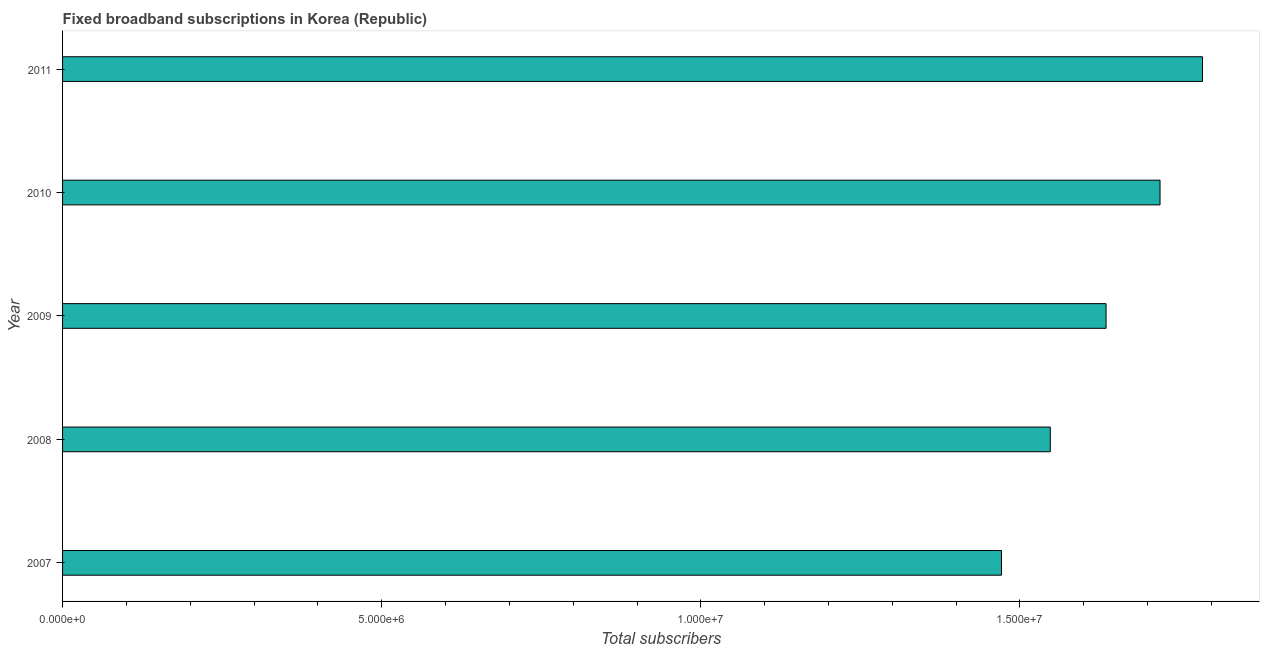Does the graph contain any zero values?
Your response must be concise. No. What is the title of the graph?
Keep it short and to the point. Fixed broadband subscriptions in Korea (Republic). What is the label or title of the X-axis?
Provide a short and direct response. Total subscribers. What is the total number of fixed broadband subscriptions in 2007?
Keep it short and to the point. 1.47e+07. Across all years, what is the maximum total number of fixed broadband subscriptions?
Keep it short and to the point. 1.79e+07. Across all years, what is the minimum total number of fixed broadband subscriptions?
Provide a succinct answer. 1.47e+07. In which year was the total number of fixed broadband subscriptions minimum?
Offer a terse response. 2007. What is the sum of the total number of fixed broadband subscriptions?
Offer a terse response. 8.16e+07. What is the difference between the total number of fixed broadband subscriptions in 2007 and 2009?
Offer a terse response. -1.64e+06. What is the average total number of fixed broadband subscriptions per year?
Your answer should be very brief. 1.63e+07. What is the median total number of fixed broadband subscriptions?
Your answer should be very brief. 1.63e+07. In how many years, is the total number of fixed broadband subscriptions greater than 2000000 ?
Make the answer very short. 5. What is the ratio of the total number of fixed broadband subscriptions in 2008 to that in 2011?
Provide a succinct answer. 0.87. Is the total number of fixed broadband subscriptions in 2007 less than that in 2009?
Provide a succinct answer. Yes. What is the difference between the highest and the second highest total number of fixed broadband subscriptions?
Provide a short and direct response. 6.65e+05. What is the difference between the highest and the lowest total number of fixed broadband subscriptions?
Keep it short and to the point. 3.15e+06. How many bars are there?
Make the answer very short. 5. Are all the bars in the graph horizontal?
Provide a short and direct response. Yes. How many years are there in the graph?
Ensure brevity in your answer.  5. What is the difference between two consecutive major ticks on the X-axis?
Your answer should be very brief. 5.00e+06. Are the values on the major ticks of X-axis written in scientific E-notation?
Ensure brevity in your answer.  Yes. What is the Total subscribers in 2007?
Keep it short and to the point. 1.47e+07. What is the Total subscribers of 2008?
Your answer should be compact. 1.55e+07. What is the Total subscribers of 2009?
Offer a terse response. 1.63e+07. What is the Total subscribers in 2010?
Give a very brief answer. 1.72e+07. What is the Total subscribers of 2011?
Offer a terse response. 1.79e+07. What is the difference between the Total subscribers in 2007 and 2008?
Offer a very short reply. -7.65e+05. What is the difference between the Total subscribers in 2007 and 2009?
Ensure brevity in your answer.  -1.64e+06. What is the difference between the Total subscribers in 2007 and 2010?
Offer a very short reply. -2.48e+06. What is the difference between the Total subscribers in 2007 and 2011?
Your answer should be very brief. -3.15e+06. What is the difference between the Total subscribers in 2008 and 2009?
Offer a very short reply. -8.74e+05. What is the difference between the Total subscribers in 2008 and 2010?
Keep it short and to the point. -1.72e+06. What is the difference between the Total subscribers in 2008 and 2011?
Offer a terse response. -2.38e+06. What is the difference between the Total subscribers in 2009 and 2010?
Provide a short and direct response. -8.46e+05. What is the difference between the Total subscribers in 2009 and 2011?
Ensure brevity in your answer.  -1.51e+06. What is the difference between the Total subscribers in 2010 and 2011?
Provide a succinct answer. -6.65e+05. What is the ratio of the Total subscribers in 2007 to that in 2008?
Keep it short and to the point. 0.95. What is the ratio of the Total subscribers in 2007 to that in 2010?
Provide a short and direct response. 0.86. What is the ratio of the Total subscribers in 2007 to that in 2011?
Offer a very short reply. 0.82. What is the ratio of the Total subscribers in 2008 to that in 2009?
Offer a very short reply. 0.95. What is the ratio of the Total subscribers in 2008 to that in 2010?
Your response must be concise. 0.9. What is the ratio of the Total subscribers in 2008 to that in 2011?
Your response must be concise. 0.87. What is the ratio of the Total subscribers in 2009 to that in 2010?
Offer a terse response. 0.95. What is the ratio of the Total subscribers in 2009 to that in 2011?
Your answer should be very brief. 0.92. What is the ratio of the Total subscribers in 2010 to that in 2011?
Your response must be concise. 0.96. 